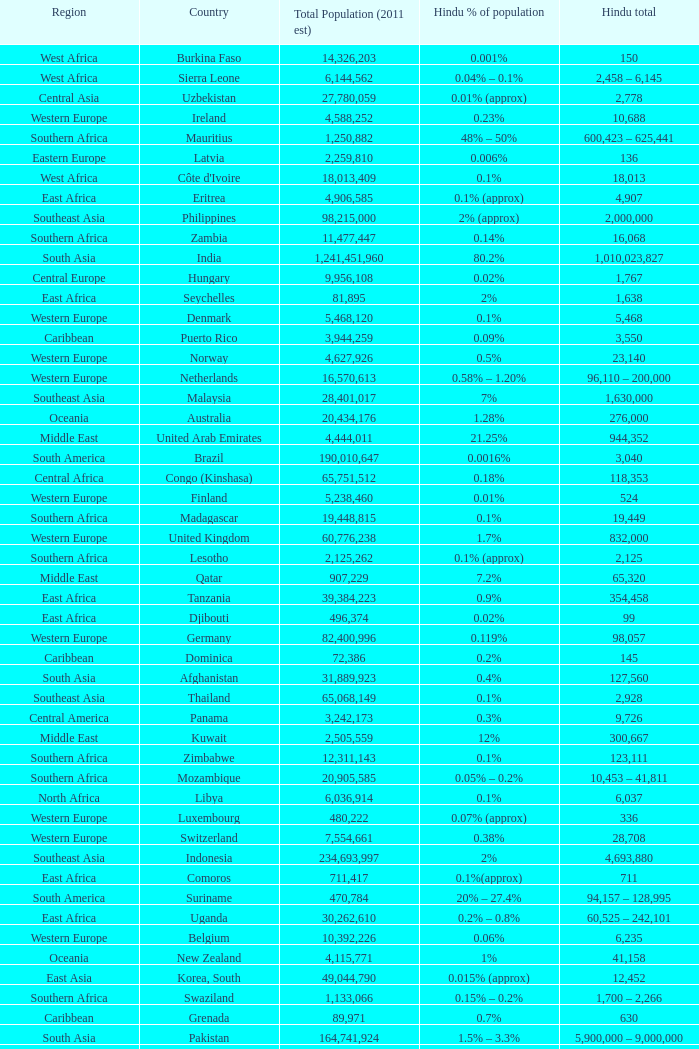Total Population (2011 est) larger than 30,262,610, and a Hindu total of 63,718 involves what country? France. 